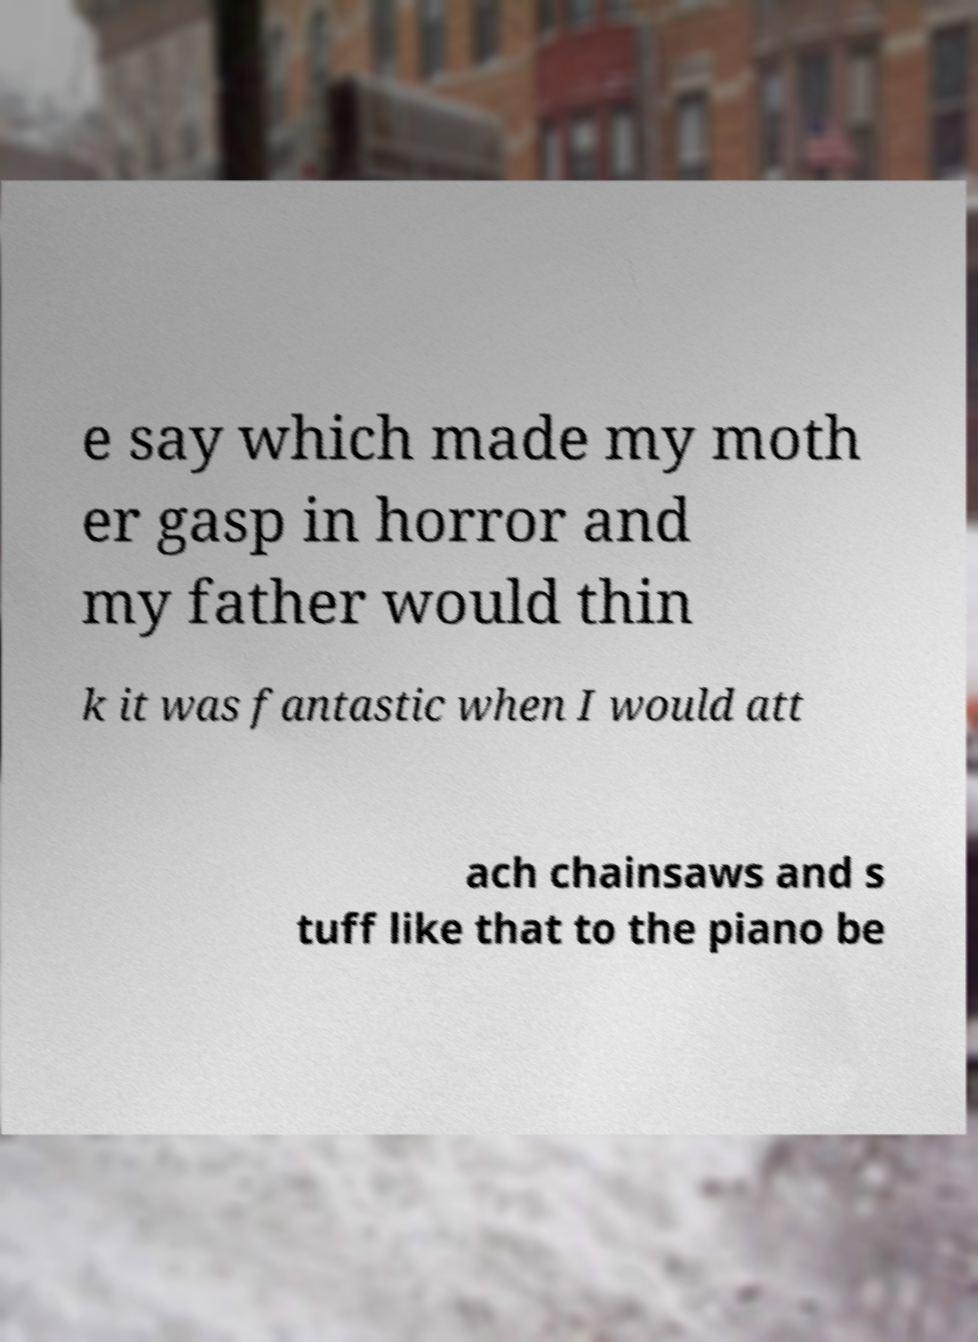What messages or text are displayed in this image? I need them in a readable, typed format. e say which made my moth er gasp in horror and my father would thin k it was fantastic when I would att ach chainsaws and s tuff like that to the piano be 